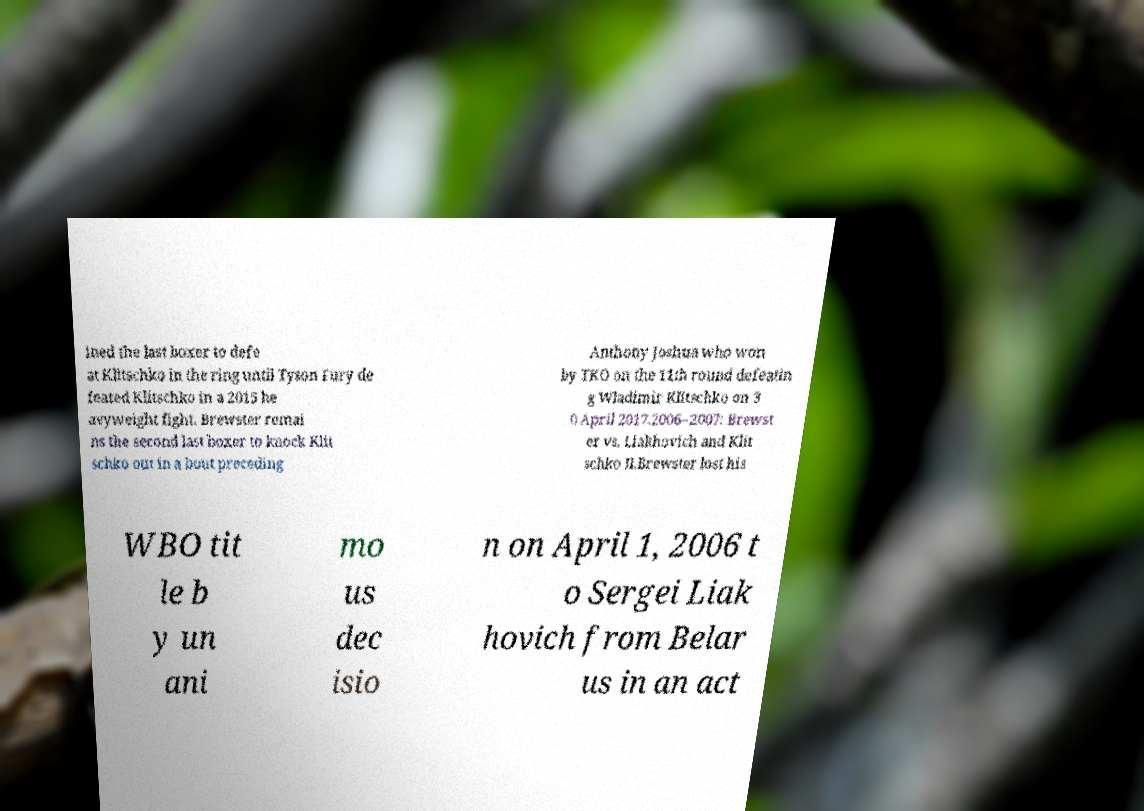What messages or text are displayed in this image? I need them in a readable, typed format. ined the last boxer to defe at Klitschko in the ring until Tyson Fury de feated Klitschko in a 2015 he avyweight fight. Brewster remai ns the second last boxer to knock Klit schko out in a bout preceding Anthony Joshua who won by TKO on the 11th round defeatin g Wladimir Klitschko on 3 0 April 2017.2006–2007: Brewst er vs. Liakhovich and Klit schko II.Brewster lost his WBO tit le b y un ani mo us dec isio n on April 1, 2006 t o Sergei Liak hovich from Belar us in an act 